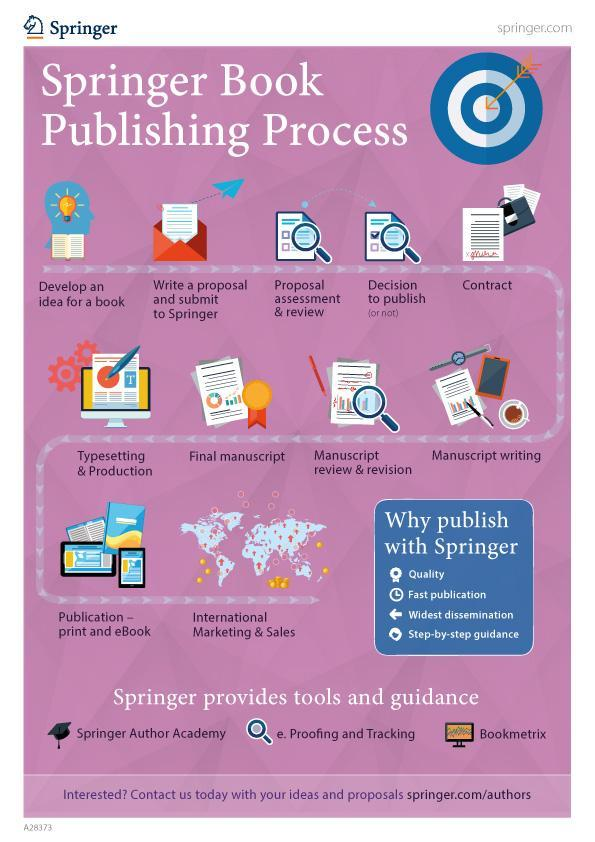what is the step before typesetting and production?
Answer the question with a short phrase. final manuscript what is the next step in publishing process after developing idea of the book? write a proposal and submit to Springer what is the next step in publishing process after publishing the book? international marketing & sales what is the next step in publishing process after making contract? manuscript writing what is the next step in publishing process after finalizing manuscript? typesetting & production what is the next step in publishing process after making decision to publish the book? contract what needs to be done right after writing manuscript? review and revision 